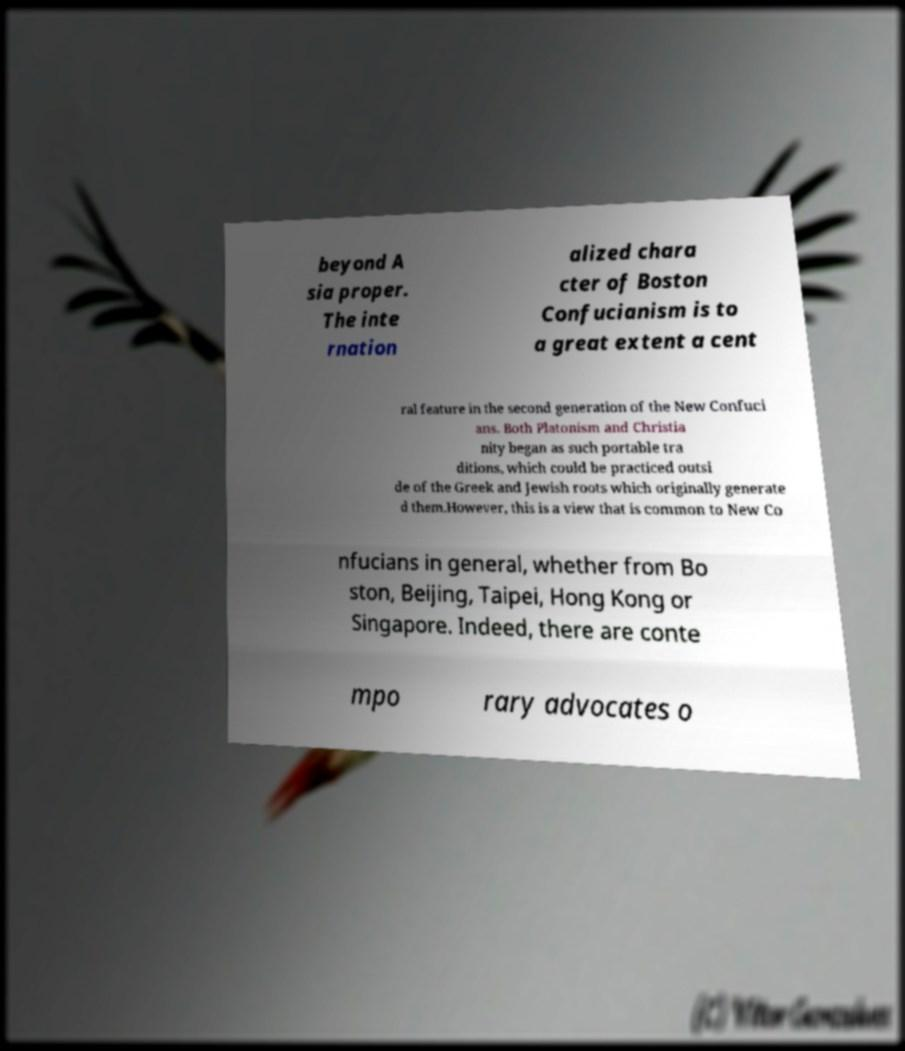What messages or text are displayed in this image? I need them in a readable, typed format. beyond A sia proper. The inte rnation alized chara cter of Boston Confucianism is to a great extent a cent ral feature in the second generation of the New Confuci ans. Both Platonism and Christia nity began as such portable tra ditions, which could be practiced outsi de of the Greek and Jewish roots which originally generate d them.However, this is a view that is common to New Co nfucians in general, whether from Bo ston, Beijing, Taipei, Hong Kong or Singapore. Indeed, there are conte mpo rary advocates o 